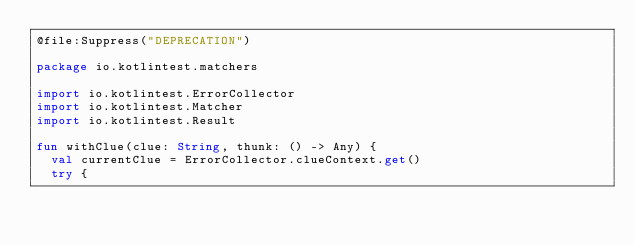Convert code to text. <code><loc_0><loc_0><loc_500><loc_500><_Kotlin_>@file:Suppress("DEPRECATION")

package io.kotlintest.matchers

import io.kotlintest.ErrorCollector
import io.kotlintest.Matcher
import io.kotlintest.Result

fun withClue(clue: String, thunk: () -> Any) {
  val currentClue = ErrorCollector.clueContext.get()
  try {</code> 